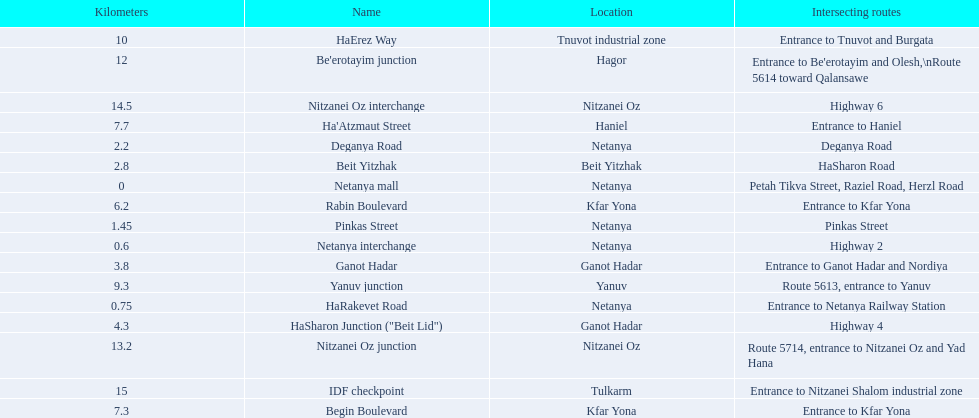Which portion has the same intersecting route as rabin boulevard? Begin Boulevard. 